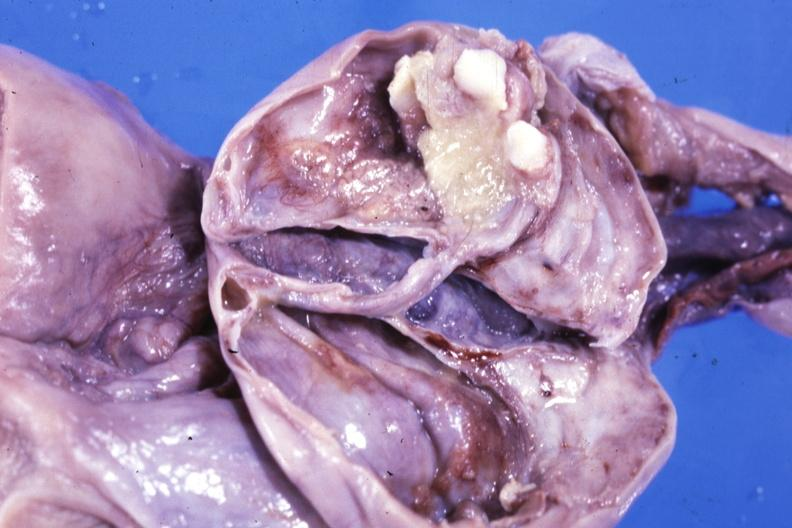how is fixed tissue opened cyst with two or three teeth?
Answer the question using a single word or phrase. Ovarian 